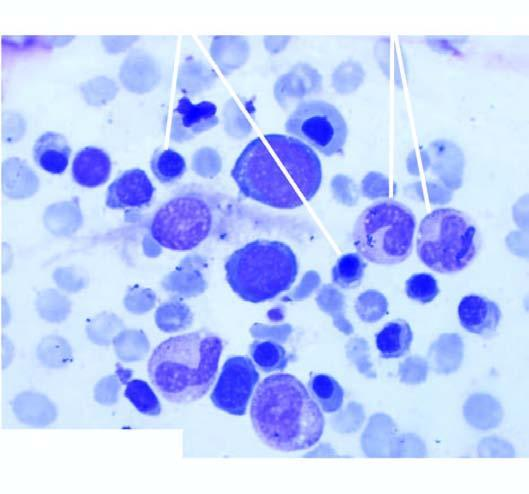does the background aspirate show micronormoblastic erythropoiesis?
Answer the question using a single word or phrase. No 